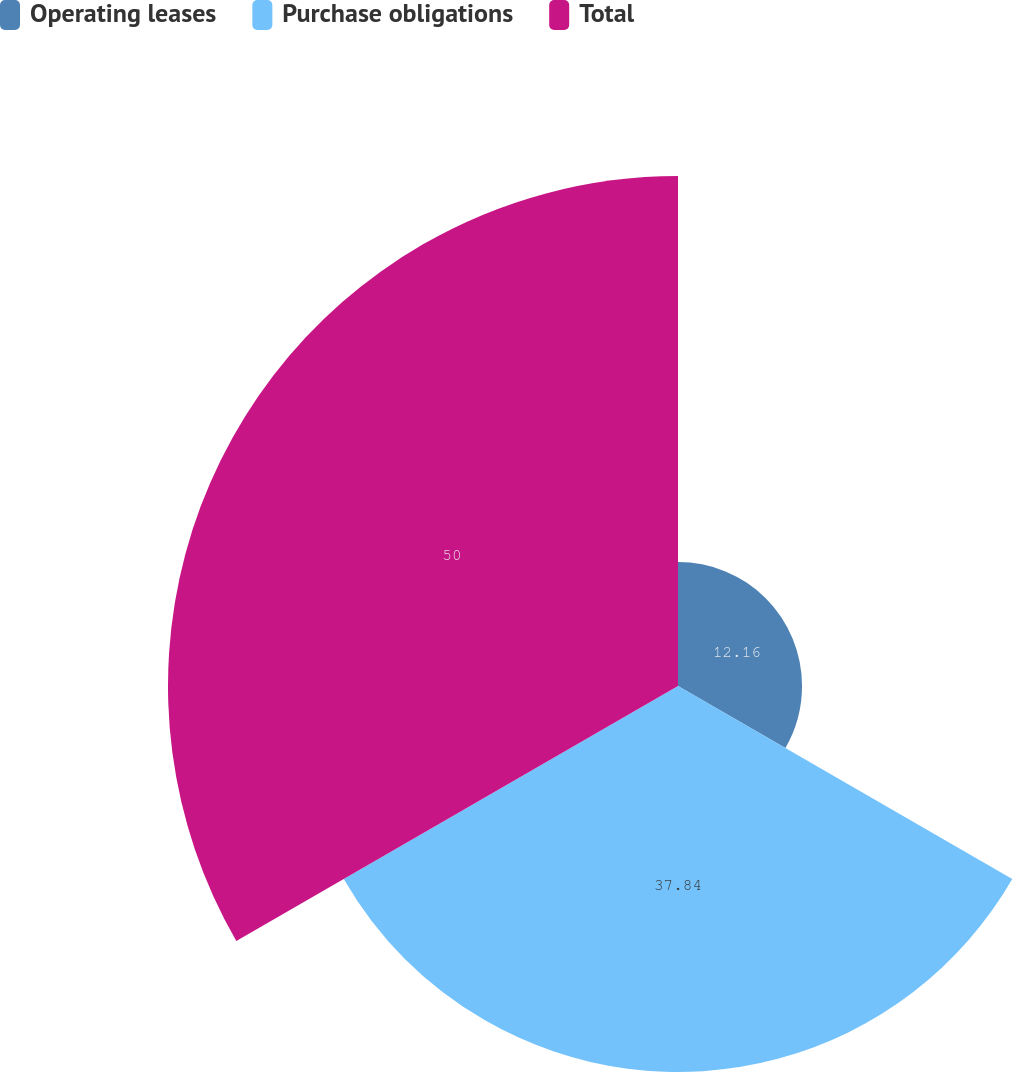Convert chart. <chart><loc_0><loc_0><loc_500><loc_500><pie_chart><fcel>Operating leases<fcel>Purchase obligations<fcel>Total<nl><fcel>12.16%<fcel>37.84%<fcel>50.0%<nl></chart> 